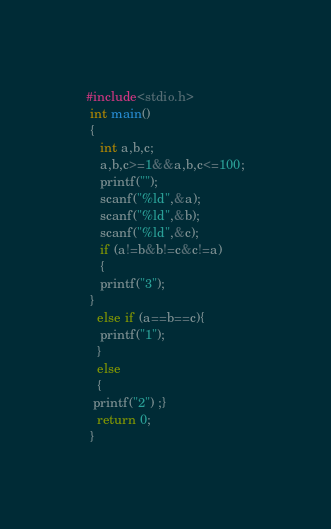Convert code to text. <code><loc_0><loc_0><loc_500><loc_500><_C_>#include<stdio.h>
 int main()
 {
 	int a,b,c;
 	a,b,c>=1&&a,b,c<=100;
 	printf("");
 	scanf("%ld",&a);
 	scanf("%ld",&b);
 	scanf("%ld",&c);
 	if (a!=b&b!=c&c!=a)
 	{
 	printf("3");
 }
   else if (a==b==c){
   	printf("1");
   }
   else
   {
  printf("2") ;}
   return 0;
 }</code> 